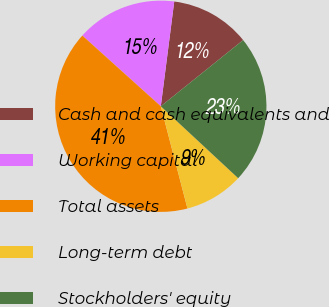<chart> <loc_0><loc_0><loc_500><loc_500><pie_chart><fcel>Cash and cash equivalents and<fcel>Working capital<fcel>Total assets<fcel>Long-term debt<fcel>Stockholders' equity<nl><fcel>12.19%<fcel>15.36%<fcel>40.74%<fcel>9.02%<fcel>22.7%<nl></chart> 